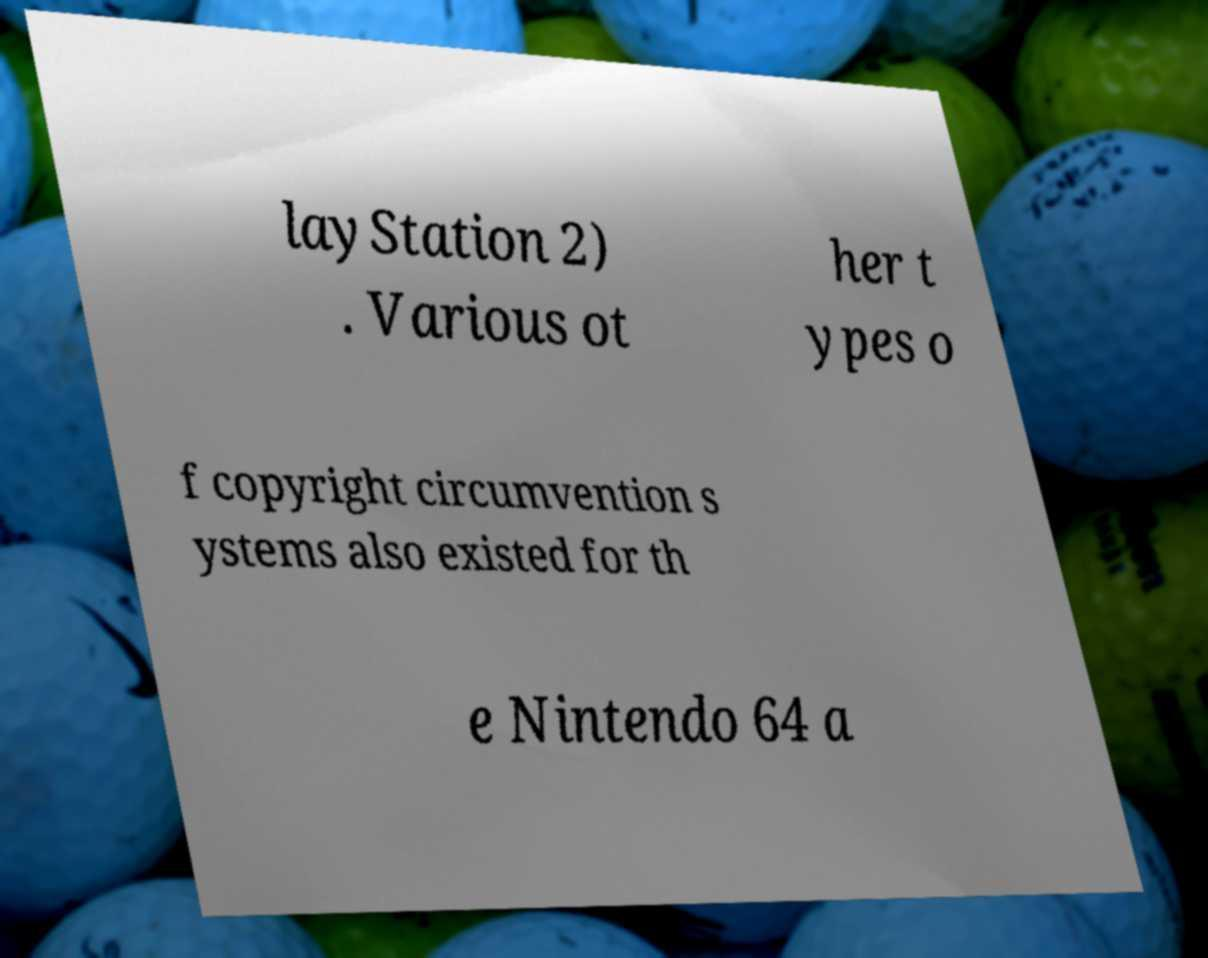There's text embedded in this image that I need extracted. Can you transcribe it verbatim? layStation 2) . Various ot her t ypes o f copyright circumvention s ystems also existed for th e Nintendo 64 a 